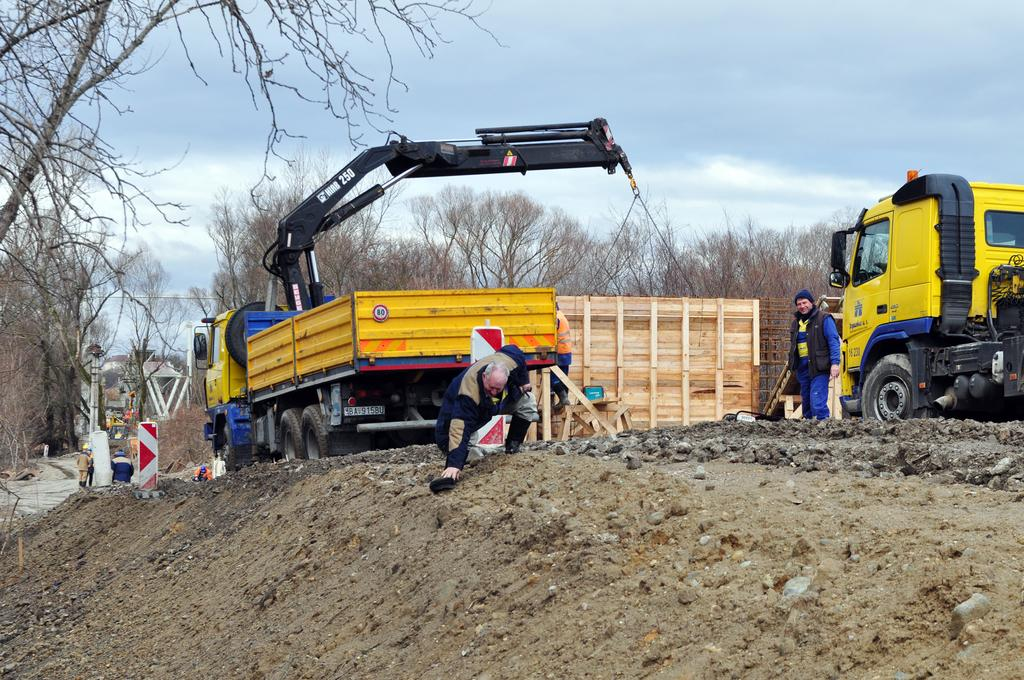What types of objects are present in the image? There are vehicles and a wooden box in the image. Can you describe the people in the image? A man is standing near the vehicle, and another man is bending in the image. What can be seen in the background of the image? There are trees and the sky visible in the background of the image. What type of insect is crawling on the wooden box in the image? There is no insect visible on the wooden box in the image. What type of sugar is being served by the man in the image? There is no man serving sugar in the image, nor is there any sugar present. 